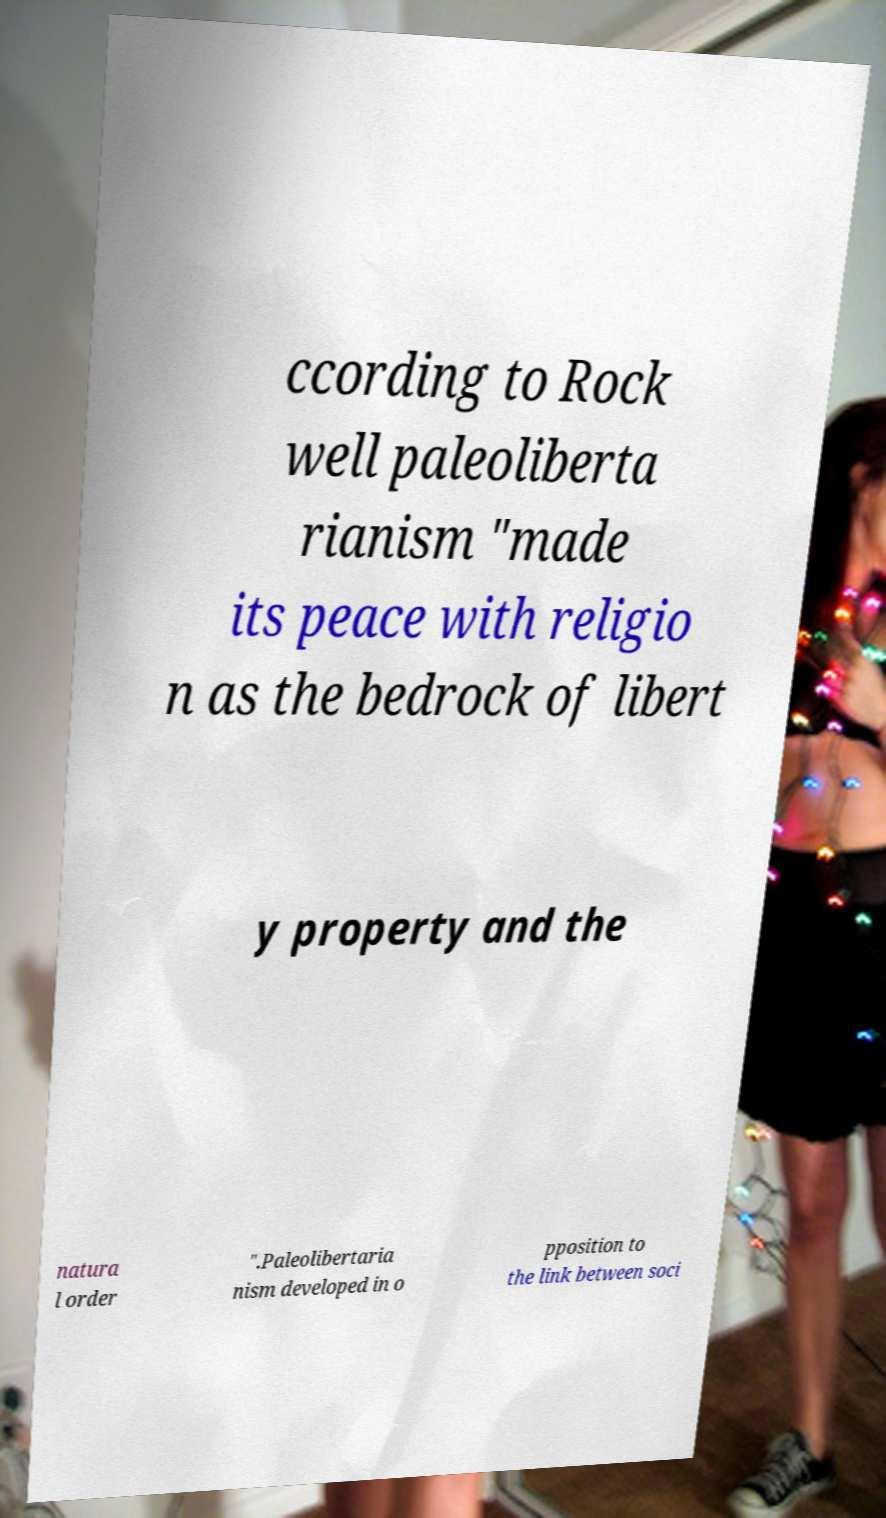I need the written content from this picture converted into text. Can you do that? ccording to Rock well paleoliberta rianism "made its peace with religio n as the bedrock of libert y property and the natura l order ".Paleolibertaria nism developed in o pposition to the link between soci 